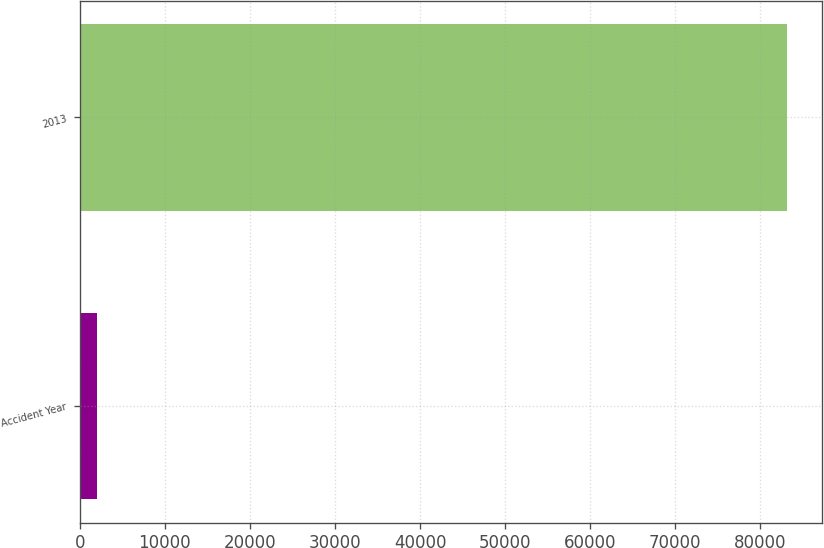Convert chart to OTSL. <chart><loc_0><loc_0><loc_500><loc_500><bar_chart><fcel>Accident Year<fcel>2013<nl><fcel>2016<fcel>83119<nl></chart> 